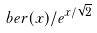Convert formula to latex. <formula><loc_0><loc_0><loc_500><loc_500>b e r ( x ) / e ^ { x / \sqrt { 2 } }</formula> 